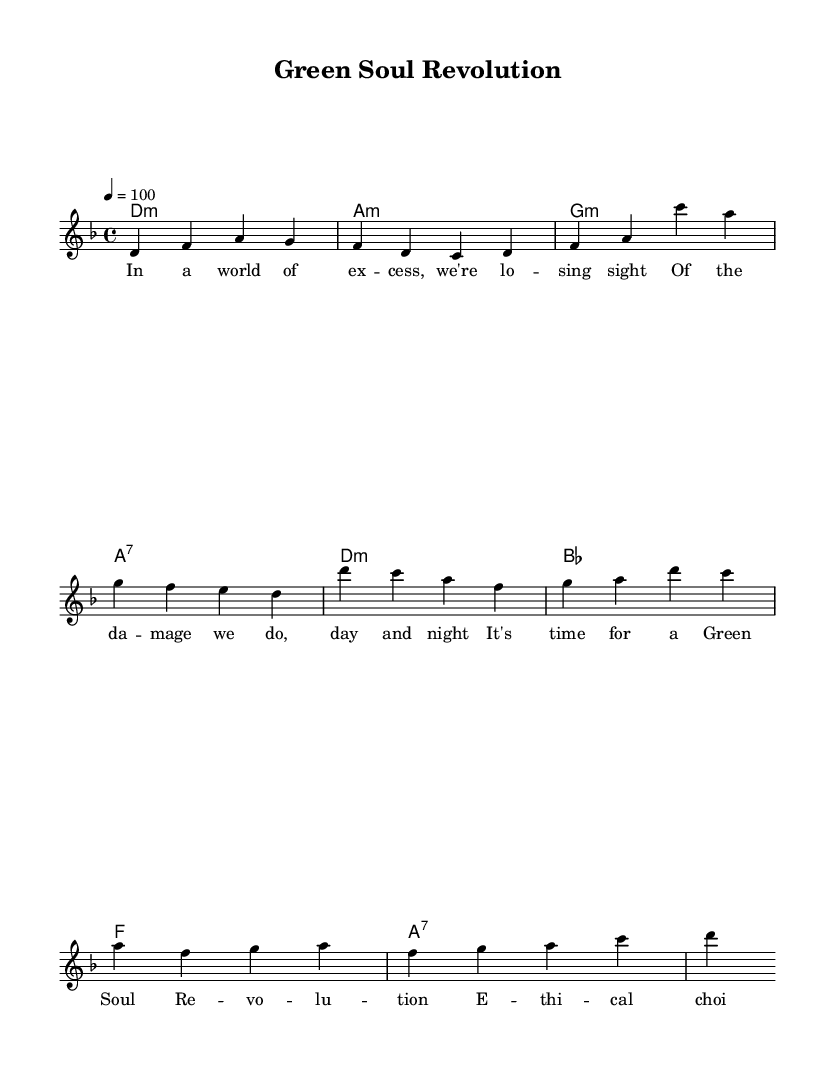What is the key signature of this music? The key signature shown in the staff indicates D minor, which has one flat (B flat). This is determined by looking at the key signature indicated at the start of the score.
Answer: D minor What is the time signature of this music? The time signature specified in the score is 4/4, which means there are four beats in each measure, and the quarter note gets one beat. This is observed in the time signature notation present at the beginning of the score.
Answer: 4/4 What is the tempo marking for this piece? The tempo marking indicates that the piece should be played at a speed of 100 beats per minute, which is noted at the beginning with the tempo indication.
Answer: 100 How many measures are in the verse section? The verse section is represented by the melody notation and contains four measures, as seen in the grouping of notes and pauses marking the end of each measure.
Answer: 4 What is the name of the song? The title of the song is given in the header section of the sheet music, stating "Green Soul Revolution." This can be identified at the top of the music sheet.
Answer: Green Soul Revolution What chords are used in the chorus? The chords used in the chorus section include D minor, B flat, F, and A7; these can be found in the harmonies section corresponding to the melody.
Answer: D minor, B flat, F, A7 How does the theme of responsible manufacturing practices manifest in the lyrics? The lyrics express a call for ethical choices and contributions, indicating a message promoting responsible practices, which is evident in the words of the chorus.
Answer: Ethical choices 